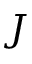<formula> <loc_0><loc_0><loc_500><loc_500>J</formula> 